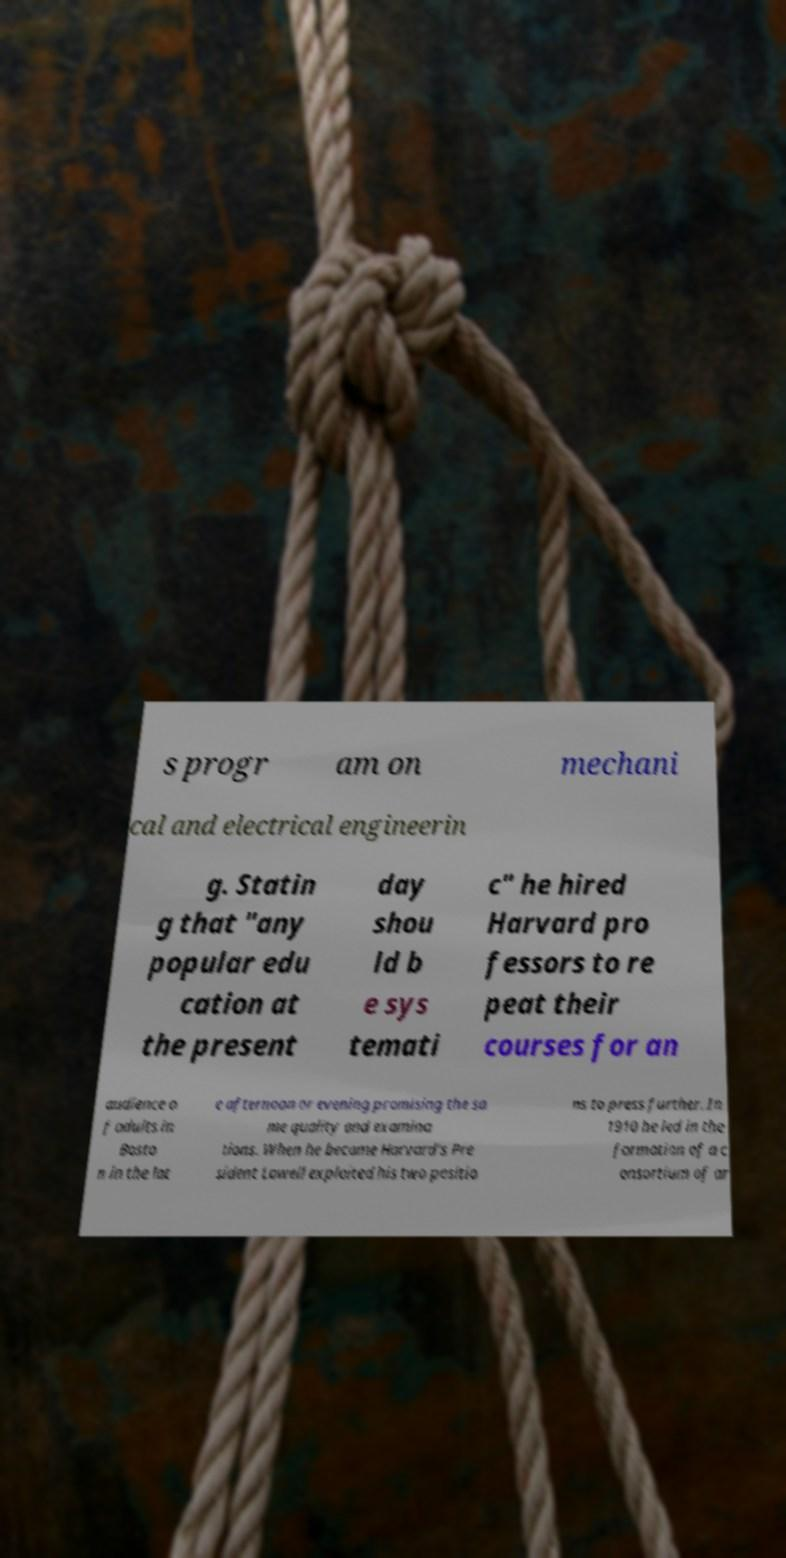Please read and relay the text visible in this image. What does it say? s progr am on mechani cal and electrical engineerin g. Statin g that "any popular edu cation at the present day shou ld b e sys temati c" he hired Harvard pro fessors to re peat their courses for an audience o f adults in Bosto n in the lat e afternoon or evening promising the sa me quality and examina tions. When he became Harvard's Pre sident Lowell exploited his two positio ns to press further. In 1910 he led in the formation of a c onsortium of ar 